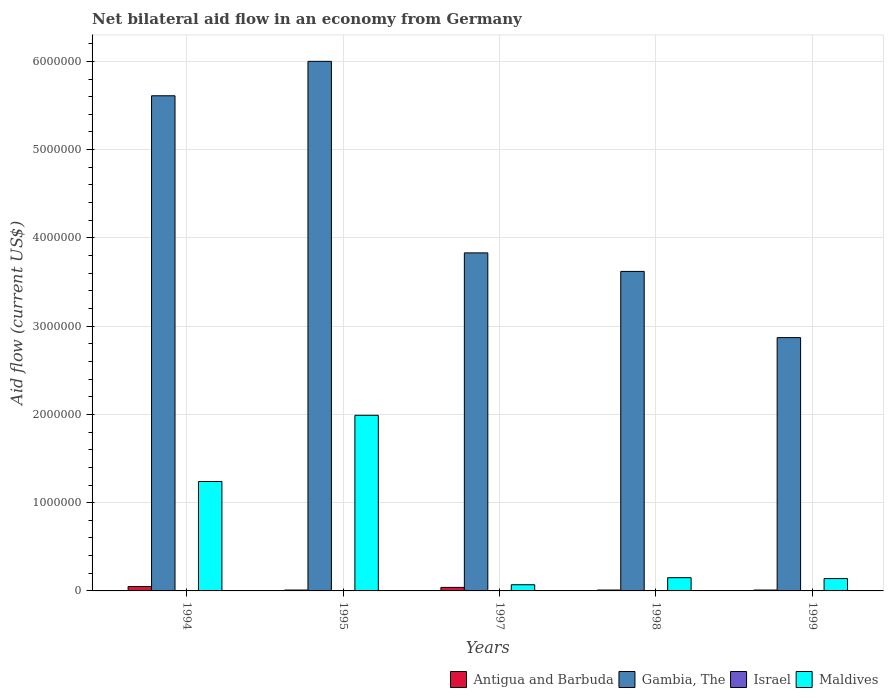How many bars are there on the 5th tick from the right?
Provide a short and direct response. 3. What is the label of the 4th group of bars from the left?
Your response must be concise. 1998. What is the net bilateral aid flow in Israel in 1997?
Give a very brief answer. 0. Across all years, what is the maximum net bilateral aid flow in Maldives?
Your answer should be very brief. 1.99e+06. Across all years, what is the minimum net bilateral aid flow in Gambia, The?
Provide a succinct answer. 2.87e+06. What is the total net bilateral aid flow in Gambia, The in the graph?
Ensure brevity in your answer.  2.19e+07. What is the difference between the net bilateral aid flow in Gambia, The in 1994 and that in 1997?
Make the answer very short. 1.78e+06. What is the difference between the net bilateral aid flow in Gambia, The in 1997 and the net bilateral aid flow in Israel in 1995?
Keep it short and to the point. 3.83e+06. What is the average net bilateral aid flow in Antigua and Barbuda per year?
Provide a succinct answer. 2.40e+04. In the year 1997, what is the difference between the net bilateral aid flow in Gambia, The and net bilateral aid flow in Maldives?
Keep it short and to the point. 3.76e+06. In how many years, is the net bilateral aid flow in Antigua and Barbuda greater than 1600000 US$?
Provide a succinct answer. 0. What is the ratio of the net bilateral aid flow in Maldives in 1994 to that in 1999?
Make the answer very short. 8.86. What is the difference between the highest and the second highest net bilateral aid flow in Maldives?
Provide a short and direct response. 7.50e+05. What is the difference between the highest and the lowest net bilateral aid flow in Gambia, The?
Offer a terse response. 3.13e+06. Is it the case that in every year, the sum of the net bilateral aid flow in Antigua and Barbuda and net bilateral aid flow in Maldives is greater than the sum of net bilateral aid flow in Israel and net bilateral aid flow in Gambia, The?
Make the answer very short. No. Is it the case that in every year, the sum of the net bilateral aid flow in Maldives and net bilateral aid flow in Antigua and Barbuda is greater than the net bilateral aid flow in Israel?
Give a very brief answer. Yes. Are all the bars in the graph horizontal?
Offer a very short reply. No. How many years are there in the graph?
Provide a short and direct response. 5. Where does the legend appear in the graph?
Provide a short and direct response. Bottom right. How are the legend labels stacked?
Ensure brevity in your answer.  Horizontal. What is the title of the graph?
Offer a very short reply. Net bilateral aid flow in an economy from Germany. What is the label or title of the X-axis?
Give a very brief answer. Years. What is the label or title of the Y-axis?
Your response must be concise. Aid flow (current US$). What is the Aid flow (current US$) in Antigua and Barbuda in 1994?
Provide a short and direct response. 5.00e+04. What is the Aid flow (current US$) in Gambia, The in 1994?
Make the answer very short. 5.61e+06. What is the Aid flow (current US$) of Israel in 1994?
Offer a terse response. 0. What is the Aid flow (current US$) in Maldives in 1994?
Your response must be concise. 1.24e+06. What is the Aid flow (current US$) in Israel in 1995?
Make the answer very short. 0. What is the Aid flow (current US$) of Maldives in 1995?
Your answer should be compact. 1.99e+06. What is the Aid flow (current US$) in Gambia, The in 1997?
Keep it short and to the point. 3.83e+06. What is the Aid flow (current US$) in Israel in 1997?
Offer a terse response. 0. What is the Aid flow (current US$) in Gambia, The in 1998?
Make the answer very short. 3.62e+06. What is the Aid flow (current US$) in Israel in 1998?
Keep it short and to the point. 0. What is the Aid flow (current US$) in Antigua and Barbuda in 1999?
Make the answer very short. 10000. What is the Aid flow (current US$) of Gambia, The in 1999?
Provide a short and direct response. 2.87e+06. What is the Aid flow (current US$) in Maldives in 1999?
Offer a very short reply. 1.40e+05. Across all years, what is the maximum Aid flow (current US$) in Gambia, The?
Your answer should be compact. 6.00e+06. Across all years, what is the maximum Aid flow (current US$) in Maldives?
Provide a short and direct response. 1.99e+06. Across all years, what is the minimum Aid flow (current US$) in Gambia, The?
Give a very brief answer. 2.87e+06. Across all years, what is the minimum Aid flow (current US$) of Maldives?
Your answer should be very brief. 7.00e+04. What is the total Aid flow (current US$) in Antigua and Barbuda in the graph?
Give a very brief answer. 1.20e+05. What is the total Aid flow (current US$) of Gambia, The in the graph?
Your answer should be compact. 2.19e+07. What is the total Aid flow (current US$) in Maldives in the graph?
Provide a succinct answer. 3.59e+06. What is the difference between the Aid flow (current US$) of Antigua and Barbuda in 1994 and that in 1995?
Keep it short and to the point. 4.00e+04. What is the difference between the Aid flow (current US$) of Gambia, The in 1994 and that in 1995?
Your response must be concise. -3.90e+05. What is the difference between the Aid flow (current US$) of Maldives in 1994 and that in 1995?
Provide a succinct answer. -7.50e+05. What is the difference between the Aid flow (current US$) in Gambia, The in 1994 and that in 1997?
Your answer should be very brief. 1.78e+06. What is the difference between the Aid flow (current US$) in Maldives in 1994 and that in 1997?
Ensure brevity in your answer.  1.17e+06. What is the difference between the Aid flow (current US$) of Antigua and Barbuda in 1994 and that in 1998?
Provide a succinct answer. 4.00e+04. What is the difference between the Aid flow (current US$) of Gambia, The in 1994 and that in 1998?
Offer a terse response. 1.99e+06. What is the difference between the Aid flow (current US$) of Maldives in 1994 and that in 1998?
Your response must be concise. 1.09e+06. What is the difference between the Aid flow (current US$) of Gambia, The in 1994 and that in 1999?
Provide a short and direct response. 2.74e+06. What is the difference between the Aid flow (current US$) in Maldives in 1994 and that in 1999?
Ensure brevity in your answer.  1.10e+06. What is the difference between the Aid flow (current US$) in Gambia, The in 1995 and that in 1997?
Your answer should be very brief. 2.17e+06. What is the difference between the Aid flow (current US$) in Maldives in 1995 and that in 1997?
Offer a terse response. 1.92e+06. What is the difference between the Aid flow (current US$) in Gambia, The in 1995 and that in 1998?
Provide a succinct answer. 2.38e+06. What is the difference between the Aid flow (current US$) in Maldives in 1995 and that in 1998?
Your answer should be compact. 1.84e+06. What is the difference between the Aid flow (current US$) in Gambia, The in 1995 and that in 1999?
Your response must be concise. 3.13e+06. What is the difference between the Aid flow (current US$) in Maldives in 1995 and that in 1999?
Give a very brief answer. 1.85e+06. What is the difference between the Aid flow (current US$) of Gambia, The in 1997 and that in 1998?
Keep it short and to the point. 2.10e+05. What is the difference between the Aid flow (current US$) in Maldives in 1997 and that in 1998?
Give a very brief answer. -8.00e+04. What is the difference between the Aid flow (current US$) in Gambia, The in 1997 and that in 1999?
Make the answer very short. 9.60e+05. What is the difference between the Aid flow (current US$) of Gambia, The in 1998 and that in 1999?
Your response must be concise. 7.50e+05. What is the difference between the Aid flow (current US$) in Maldives in 1998 and that in 1999?
Give a very brief answer. 10000. What is the difference between the Aid flow (current US$) in Antigua and Barbuda in 1994 and the Aid flow (current US$) in Gambia, The in 1995?
Give a very brief answer. -5.95e+06. What is the difference between the Aid flow (current US$) of Antigua and Barbuda in 1994 and the Aid flow (current US$) of Maldives in 1995?
Offer a terse response. -1.94e+06. What is the difference between the Aid flow (current US$) in Gambia, The in 1994 and the Aid flow (current US$) in Maldives in 1995?
Provide a short and direct response. 3.62e+06. What is the difference between the Aid flow (current US$) in Antigua and Barbuda in 1994 and the Aid flow (current US$) in Gambia, The in 1997?
Offer a very short reply. -3.78e+06. What is the difference between the Aid flow (current US$) of Antigua and Barbuda in 1994 and the Aid flow (current US$) of Maldives in 1997?
Provide a short and direct response. -2.00e+04. What is the difference between the Aid flow (current US$) of Gambia, The in 1994 and the Aid flow (current US$) of Maldives in 1997?
Give a very brief answer. 5.54e+06. What is the difference between the Aid flow (current US$) of Antigua and Barbuda in 1994 and the Aid flow (current US$) of Gambia, The in 1998?
Your answer should be compact. -3.57e+06. What is the difference between the Aid flow (current US$) of Gambia, The in 1994 and the Aid flow (current US$) of Maldives in 1998?
Offer a very short reply. 5.46e+06. What is the difference between the Aid flow (current US$) of Antigua and Barbuda in 1994 and the Aid flow (current US$) of Gambia, The in 1999?
Offer a very short reply. -2.82e+06. What is the difference between the Aid flow (current US$) in Gambia, The in 1994 and the Aid flow (current US$) in Maldives in 1999?
Your response must be concise. 5.47e+06. What is the difference between the Aid flow (current US$) in Antigua and Barbuda in 1995 and the Aid flow (current US$) in Gambia, The in 1997?
Ensure brevity in your answer.  -3.82e+06. What is the difference between the Aid flow (current US$) in Gambia, The in 1995 and the Aid flow (current US$) in Maldives in 1997?
Ensure brevity in your answer.  5.93e+06. What is the difference between the Aid flow (current US$) of Antigua and Barbuda in 1995 and the Aid flow (current US$) of Gambia, The in 1998?
Keep it short and to the point. -3.61e+06. What is the difference between the Aid flow (current US$) in Gambia, The in 1995 and the Aid flow (current US$) in Maldives in 1998?
Your response must be concise. 5.85e+06. What is the difference between the Aid flow (current US$) in Antigua and Barbuda in 1995 and the Aid flow (current US$) in Gambia, The in 1999?
Provide a short and direct response. -2.86e+06. What is the difference between the Aid flow (current US$) of Gambia, The in 1995 and the Aid flow (current US$) of Maldives in 1999?
Your response must be concise. 5.86e+06. What is the difference between the Aid flow (current US$) of Antigua and Barbuda in 1997 and the Aid flow (current US$) of Gambia, The in 1998?
Your answer should be very brief. -3.58e+06. What is the difference between the Aid flow (current US$) in Gambia, The in 1997 and the Aid flow (current US$) in Maldives in 1998?
Give a very brief answer. 3.68e+06. What is the difference between the Aid flow (current US$) in Antigua and Barbuda in 1997 and the Aid flow (current US$) in Gambia, The in 1999?
Offer a terse response. -2.83e+06. What is the difference between the Aid flow (current US$) in Gambia, The in 1997 and the Aid flow (current US$) in Maldives in 1999?
Make the answer very short. 3.69e+06. What is the difference between the Aid flow (current US$) in Antigua and Barbuda in 1998 and the Aid flow (current US$) in Gambia, The in 1999?
Ensure brevity in your answer.  -2.86e+06. What is the difference between the Aid flow (current US$) of Gambia, The in 1998 and the Aid flow (current US$) of Maldives in 1999?
Your answer should be very brief. 3.48e+06. What is the average Aid flow (current US$) in Antigua and Barbuda per year?
Your answer should be compact. 2.40e+04. What is the average Aid flow (current US$) in Gambia, The per year?
Provide a succinct answer. 4.39e+06. What is the average Aid flow (current US$) of Maldives per year?
Make the answer very short. 7.18e+05. In the year 1994, what is the difference between the Aid flow (current US$) in Antigua and Barbuda and Aid flow (current US$) in Gambia, The?
Make the answer very short. -5.56e+06. In the year 1994, what is the difference between the Aid flow (current US$) of Antigua and Barbuda and Aid flow (current US$) of Maldives?
Give a very brief answer. -1.19e+06. In the year 1994, what is the difference between the Aid flow (current US$) in Gambia, The and Aid flow (current US$) in Maldives?
Your answer should be very brief. 4.37e+06. In the year 1995, what is the difference between the Aid flow (current US$) of Antigua and Barbuda and Aid flow (current US$) of Gambia, The?
Offer a terse response. -5.99e+06. In the year 1995, what is the difference between the Aid flow (current US$) of Antigua and Barbuda and Aid flow (current US$) of Maldives?
Offer a terse response. -1.98e+06. In the year 1995, what is the difference between the Aid flow (current US$) of Gambia, The and Aid flow (current US$) of Maldives?
Keep it short and to the point. 4.01e+06. In the year 1997, what is the difference between the Aid flow (current US$) of Antigua and Barbuda and Aid flow (current US$) of Gambia, The?
Your answer should be compact. -3.79e+06. In the year 1997, what is the difference between the Aid flow (current US$) of Gambia, The and Aid flow (current US$) of Maldives?
Provide a succinct answer. 3.76e+06. In the year 1998, what is the difference between the Aid flow (current US$) of Antigua and Barbuda and Aid flow (current US$) of Gambia, The?
Provide a succinct answer. -3.61e+06. In the year 1998, what is the difference between the Aid flow (current US$) of Gambia, The and Aid flow (current US$) of Maldives?
Keep it short and to the point. 3.47e+06. In the year 1999, what is the difference between the Aid flow (current US$) in Antigua and Barbuda and Aid flow (current US$) in Gambia, The?
Keep it short and to the point. -2.86e+06. In the year 1999, what is the difference between the Aid flow (current US$) of Gambia, The and Aid flow (current US$) of Maldives?
Provide a succinct answer. 2.73e+06. What is the ratio of the Aid flow (current US$) in Gambia, The in 1994 to that in 1995?
Offer a terse response. 0.94. What is the ratio of the Aid flow (current US$) of Maldives in 1994 to that in 1995?
Your answer should be compact. 0.62. What is the ratio of the Aid flow (current US$) of Antigua and Barbuda in 1994 to that in 1997?
Your answer should be compact. 1.25. What is the ratio of the Aid flow (current US$) of Gambia, The in 1994 to that in 1997?
Your answer should be very brief. 1.46. What is the ratio of the Aid flow (current US$) in Maldives in 1994 to that in 1997?
Your response must be concise. 17.71. What is the ratio of the Aid flow (current US$) in Gambia, The in 1994 to that in 1998?
Ensure brevity in your answer.  1.55. What is the ratio of the Aid flow (current US$) in Maldives in 1994 to that in 1998?
Make the answer very short. 8.27. What is the ratio of the Aid flow (current US$) of Gambia, The in 1994 to that in 1999?
Ensure brevity in your answer.  1.95. What is the ratio of the Aid flow (current US$) in Maldives in 1994 to that in 1999?
Your response must be concise. 8.86. What is the ratio of the Aid flow (current US$) in Antigua and Barbuda in 1995 to that in 1997?
Your response must be concise. 0.25. What is the ratio of the Aid flow (current US$) in Gambia, The in 1995 to that in 1997?
Provide a succinct answer. 1.57. What is the ratio of the Aid flow (current US$) in Maldives in 1995 to that in 1997?
Provide a short and direct response. 28.43. What is the ratio of the Aid flow (current US$) of Antigua and Barbuda in 1995 to that in 1998?
Provide a succinct answer. 1. What is the ratio of the Aid flow (current US$) in Gambia, The in 1995 to that in 1998?
Your response must be concise. 1.66. What is the ratio of the Aid flow (current US$) of Maldives in 1995 to that in 1998?
Provide a short and direct response. 13.27. What is the ratio of the Aid flow (current US$) of Antigua and Barbuda in 1995 to that in 1999?
Provide a succinct answer. 1. What is the ratio of the Aid flow (current US$) of Gambia, The in 1995 to that in 1999?
Your response must be concise. 2.09. What is the ratio of the Aid flow (current US$) of Maldives in 1995 to that in 1999?
Ensure brevity in your answer.  14.21. What is the ratio of the Aid flow (current US$) in Antigua and Barbuda in 1997 to that in 1998?
Your response must be concise. 4. What is the ratio of the Aid flow (current US$) in Gambia, The in 1997 to that in 1998?
Provide a short and direct response. 1.06. What is the ratio of the Aid flow (current US$) in Maldives in 1997 to that in 1998?
Provide a short and direct response. 0.47. What is the ratio of the Aid flow (current US$) in Antigua and Barbuda in 1997 to that in 1999?
Your response must be concise. 4. What is the ratio of the Aid flow (current US$) of Gambia, The in 1997 to that in 1999?
Your answer should be very brief. 1.33. What is the ratio of the Aid flow (current US$) of Maldives in 1997 to that in 1999?
Your answer should be very brief. 0.5. What is the ratio of the Aid flow (current US$) of Antigua and Barbuda in 1998 to that in 1999?
Offer a very short reply. 1. What is the ratio of the Aid flow (current US$) of Gambia, The in 1998 to that in 1999?
Make the answer very short. 1.26. What is the ratio of the Aid flow (current US$) in Maldives in 1998 to that in 1999?
Provide a short and direct response. 1.07. What is the difference between the highest and the second highest Aid flow (current US$) of Antigua and Barbuda?
Your response must be concise. 10000. What is the difference between the highest and the second highest Aid flow (current US$) of Gambia, The?
Ensure brevity in your answer.  3.90e+05. What is the difference between the highest and the second highest Aid flow (current US$) of Maldives?
Provide a succinct answer. 7.50e+05. What is the difference between the highest and the lowest Aid flow (current US$) of Gambia, The?
Your response must be concise. 3.13e+06. What is the difference between the highest and the lowest Aid flow (current US$) in Maldives?
Your response must be concise. 1.92e+06. 